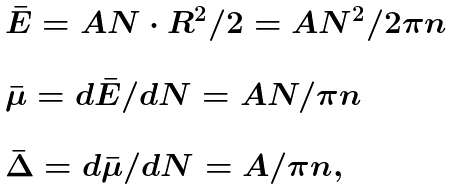<formula> <loc_0><loc_0><loc_500><loc_500>\begin{array} { l } { \bar { E } = A N \cdot R ^ { 2 } / 2 = A N ^ { 2 } / 2 \pi n } \\ \\ { \bar { \mu } = d \bar { E } / d N = A N / \pi n } \\ \\ { \bar { \Delta } = d \bar { \mu } / d N = A / \pi n } , \end{array}</formula> 